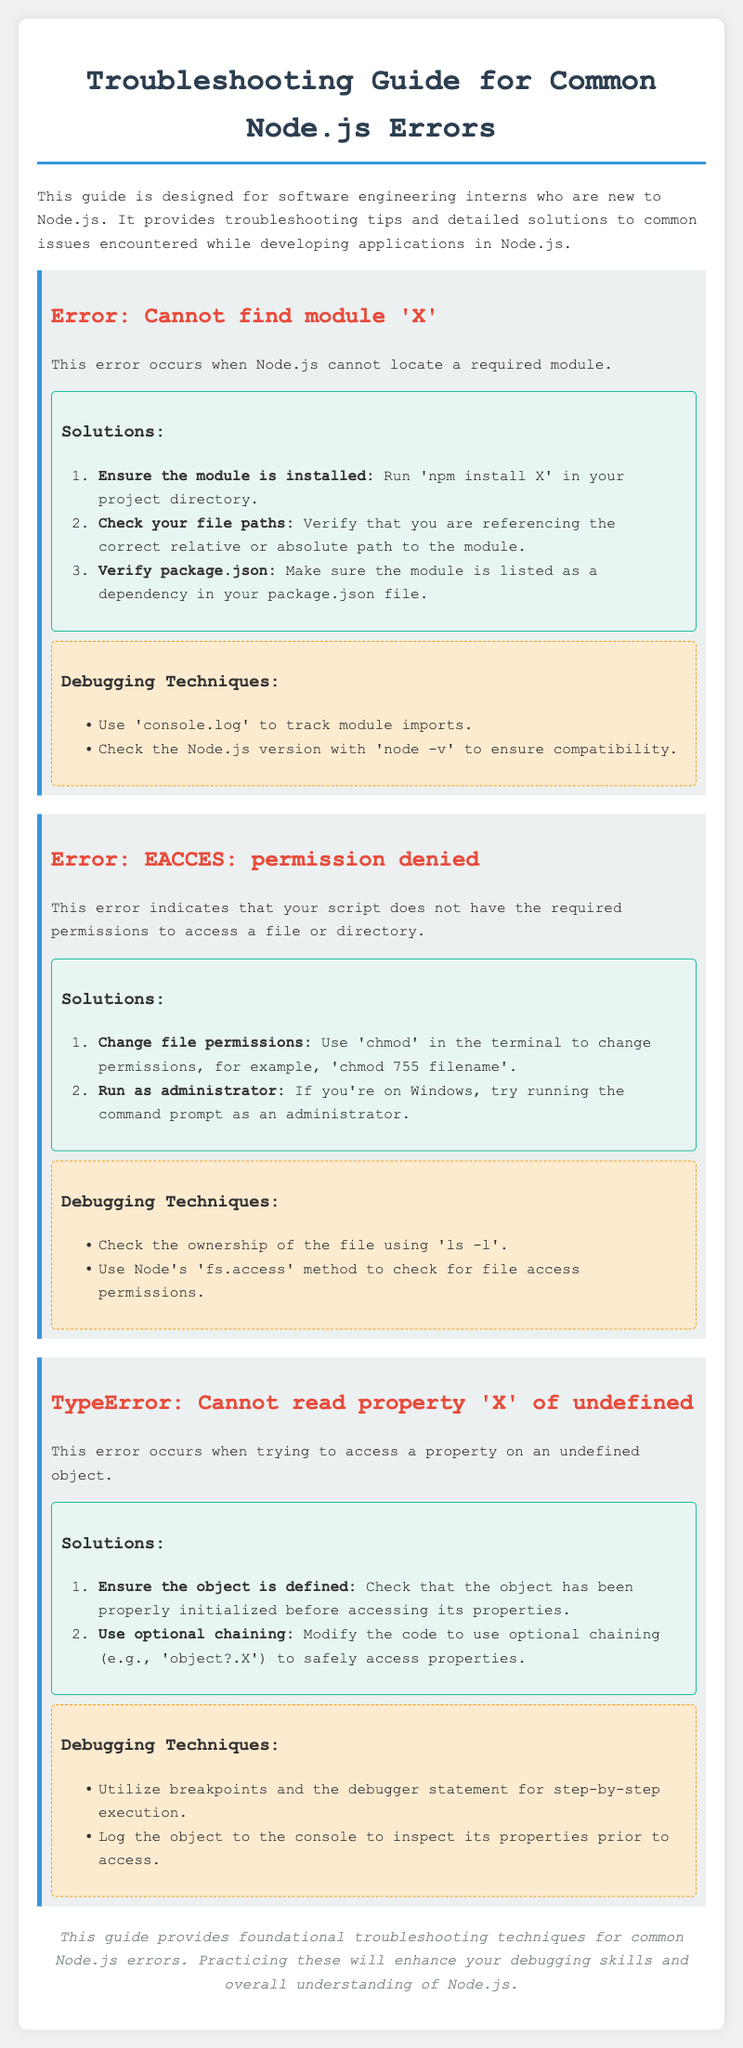What is the title of the document? The title is found in the <title> tag of the document, which is presented at the top.
Answer: Node.js Troubleshooting Guide for Interns What is the first error described in the guide? The first error is titled in the document's section, highlighted in bold.
Answer: Cannot find module 'X' What permission-related error is mentioned in the guide? This error is clearly stated under its specific error section regarding permission issues.
Answer: EACCES: permission denied How can you ensure a module is installed according to the guide? The guide provides instructions, specifically mentioning the command to be run in the project directory.
Answer: npm install X What debugging technique is recommended for checking file access permissions? The specific method mentioned in the document relates to a Node method for file access.
Answer: fs.access What is the suggested way to safely access properties of an object to avoid errors? The document discusses a JavaScript feature that allows for safe property access.
Answer: Optional chaining What command should you use to change file permissions? The guide mentions a command that is commonly used for modifying file permissions.
Answer: chmod What is the last note in the conclusion of the document? The conclusion summarizes the training aim of the guide, emphasizing the impact on skills.
Answer: Enhance your debugging skills and overall understanding of Node.js 